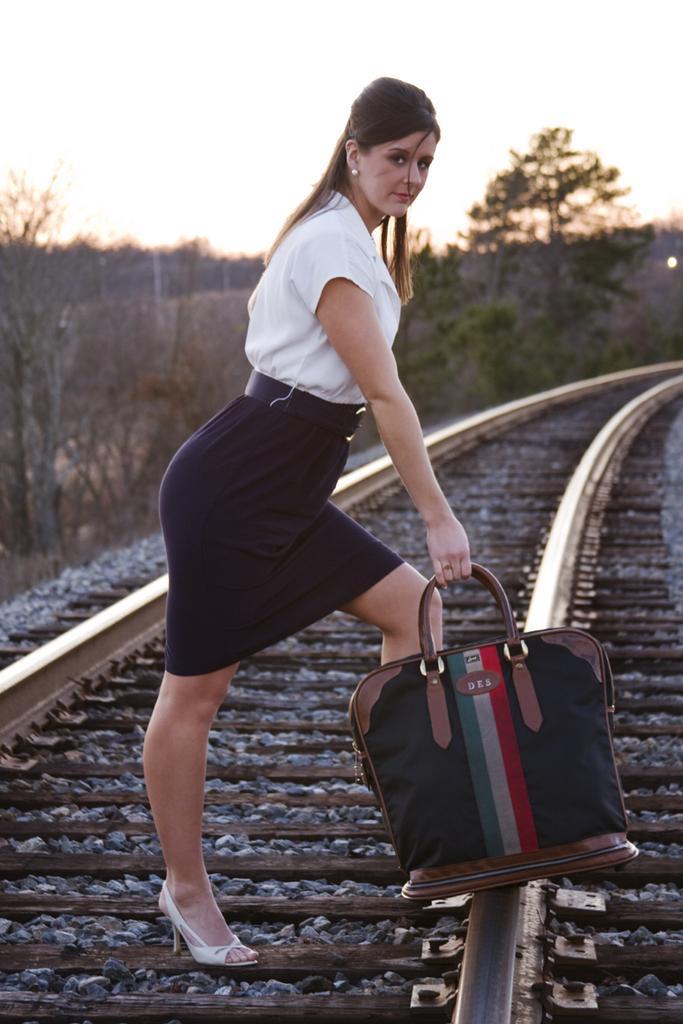Please provide a concise description of this image. At the top we can see sky, trees and a bare tree. Here we can see one women standing on a railway track and she is holding a bag in her hand. 